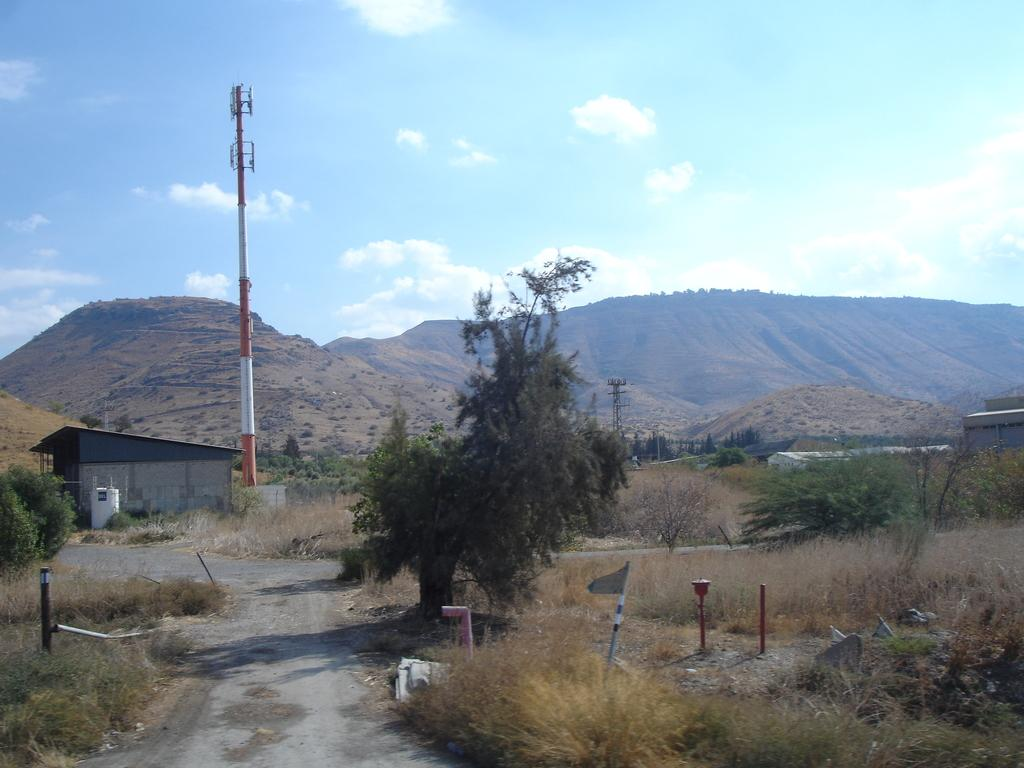What type of vegetation can be seen in the image? There are trees in the image. What is located in front of the trees? There is a pole in front of the trees. What natural feature can be seen in the distance in the image? There are mountains visible in the background of the image. Can you tell me how many toads are sitting on the pole in the image? There are no toads present in the image; it features trees, a pole, and mountains in the background. 